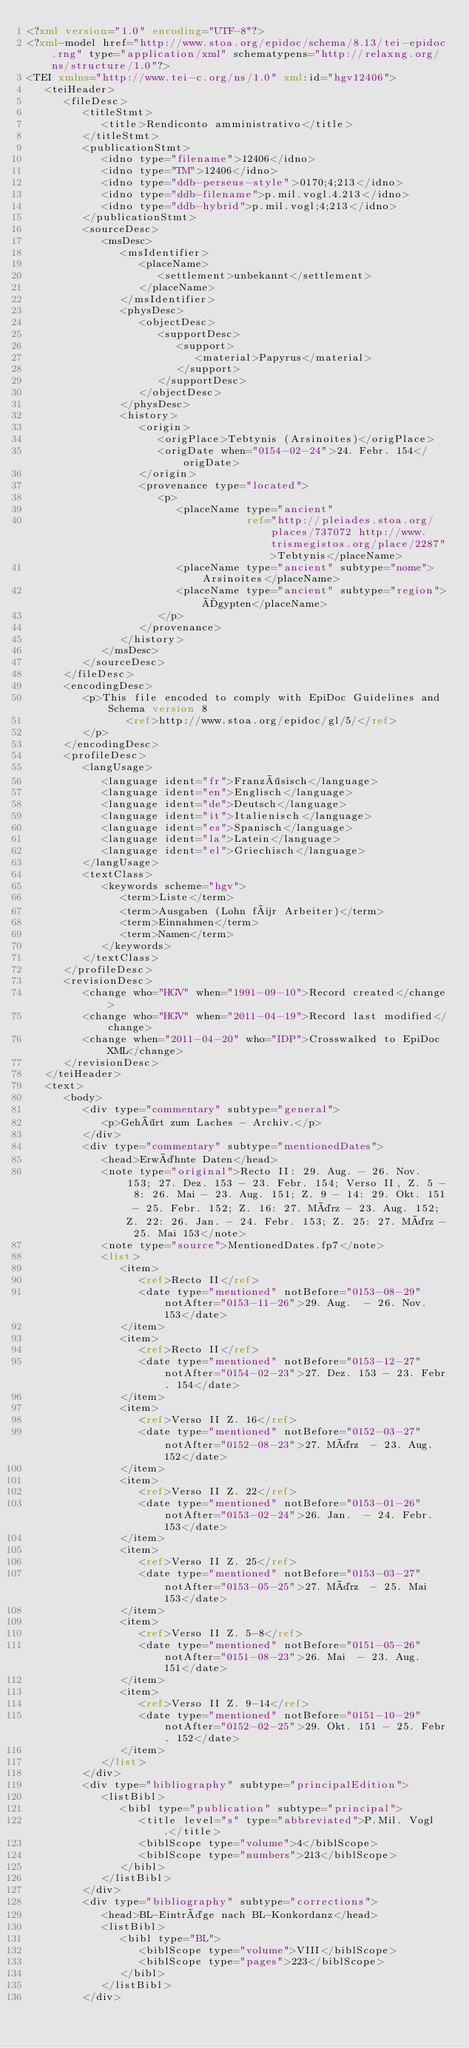<code> <loc_0><loc_0><loc_500><loc_500><_XML_><?xml version="1.0" encoding="UTF-8"?>
<?xml-model href="http://www.stoa.org/epidoc/schema/8.13/tei-epidoc.rng" type="application/xml" schematypens="http://relaxng.org/ns/structure/1.0"?>
<TEI xmlns="http://www.tei-c.org/ns/1.0" xml:id="hgv12406">
   <teiHeader>
      <fileDesc>
         <titleStmt>
            <title>Rendiconto amministrativo</title>
         </titleStmt>
         <publicationStmt>
            <idno type="filename">12406</idno>
            <idno type="TM">12406</idno>
            <idno type="ddb-perseus-style">0170;4;213</idno>
            <idno type="ddb-filename">p.mil.vogl.4.213</idno>
            <idno type="ddb-hybrid">p.mil.vogl;4;213</idno>
         </publicationStmt>
         <sourceDesc>
            <msDesc>
               <msIdentifier>
                  <placeName>
                     <settlement>unbekannt</settlement>
                  </placeName>
               </msIdentifier>
               <physDesc>
                  <objectDesc>
                     <supportDesc>
                        <support>
                           <material>Papyrus</material>
                        </support>
                     </supportDesc>
                  </objectDesc>
               </physDesc>
               <history>
                  <origin>
                     <origPlace>Tebtynis (Arsinoites)</origPlace>
                     <origDate when="0154-02-24">24. Febr. 154</origDate>
                  </origin>
                  <provenance type="located">
                     <p>
                        <placeName type="ancient"
                                   ref="http://pleiades.stoa.org/places/737072 http://www.trismegistos.org/place/2287">Tebtynis</placeName>
                        <placeName type="ancient" subtype="nome">Arsinoites</placeName>
                        <placeName type="ancient" subtype="region">Ägypten</placeName>
                     </p>
                  </provenance>
               </history>
            </msDesc>
         </sourceDesc>
      </fileDesc>
      <encodingDesc>
         <p>This file encoded to comply with EpiDoc Guidelines and Schema version 8
                <ref>http://www.stoa.org/epidoc/gl/5/</ref>
         </p>
      </encodingDesc>
      <profileDesc>
         <langUsage>
            <language ident="fr">Französisch</language>
            <language ident="en">Englisch</language>
            <language ident="de">Deutsch</language>
            <language ident="it">Italienisch</language>
            <language ident="es">Spanisch</language>
            <language ident="la">Latein</language>
            <language ident="el">Griechisch</language>
         </langUsage>
         <textClass>
            <keywords scheme="hgv">
               <term>Liste</term>
               <term>Ausgaben (Lohn für Arbeiter)</term>
               <term>Einnahmen</term>
               <term>Namen</term>
            </keywords>
         </textClass>
      </profileDesc>
      <revisionDesc>
         <change who="HGV" when="1991-09-10">Record created</change>
         <change who="HGV" when="2011-04-19">Record last modified</change>
         <change when="2011-04-20" who="IDP">Crosswalked to EpiDoc XML</change>
      </revisionDesc>
   </teiHeader>
   <text>
      <body>
         <div type="commentary" subtype="general">
            <p>Gehört zum Laches - Archiv.</p>
         </div>
         <div type="commentary" subtype="mentionedDates">
            <head>Erwähnte Daten</head>
            <note type="original">Recto II: 29. Aug. - 26. Nov. 153; 27. Dez. 153 - 23. Febr. 154; Verso II, Z. 5 - 8: 26. Mai - 23. Aug. 151; Z. 9 - 14: 29. Okt. 151 - 25. Febr. 152; Z. 16: 27. März - 23. Aug. 152; Z. 22: 26. Jan. - 24. Febr. 153; Z. 25: 27. März - 25. Mai 153</note>
            <note type="source">MentionedDates.fp7</note>
            <list>
               <item>
                  <ref>Recto II</ref>
                  <date type="mentioned" notBefore="0153-08-29" notAfter="0153-11-26">29. Aug.  - 26. Nov. 153</date>
               </item>
               <item>
                  <ref>Recto II</ref>
                  <date type="mentioned" notBefore="0153-12-27" notAfter="0154-02-23">27. Dez. 153 - 23. Febr. 154</date>
               </item>
               <item>
                  <ref>Verso II Z. 16</ref>
                  <date type="mentioned" notBefore="0152-03-27" notAfter="0152-08-23">27. März  - 23. Aug. 152</date>
               </item>
               <item>
                  <ref>Verso II Z. 22</ref>
                  <date type="mentioned" notBefore="0153-01-26" notAfter="0153-02-24">26. Jan.  - 24. Febr. 153</date>
               </item>
               <item>
                  <ref>Verso II Z. 25</ref>
                  <date type="mentioned" notBefore="0153-03-27" notAfter="0153-05-25">27. März  - 25. Mai 153</date>
               </item>
               <item>
                  <ref>Verso II Z. 5-8</ref>
                  <date type="mentioned" notBefore="0151-05-26" notAfter="0151-08-23">26. Mai  - 23. Aug. 151</date>
               </item>
               <item>
                  <ref>Verso II Z. 9-14</ref>
                  <date type="mentioned" notBefore="0151-10-29" notAfter="0152-02-25">29. Okt. 151 - 25. Febr. 152</date>
               </item>
            </list>
         </div>
         <div type="bibliography" subtype="principalEdition">
            <listBibl>
               <bibl type="publication" subtype="principal">
                  <title level="s" type="abbreviated">P.Mil. Vogl.</title>
                  <biblScope type="volume">4</biblScope>
                  <biblScope type="numbers">213</biblScope>
               </bibl>
            </listBibl>
         </div>
         <div type="bibliography" subtype="corrections">
            <head>BL-Einträge nach BL-Konkordanz</head>
            <listBibl>
               <bibl type="BL">
                  <biblScope type="volume">VIII</biblScope>
                  <biblScope type="pages">223</biblScope>
               </bibl>
            </listBibl>
         </div></code> 